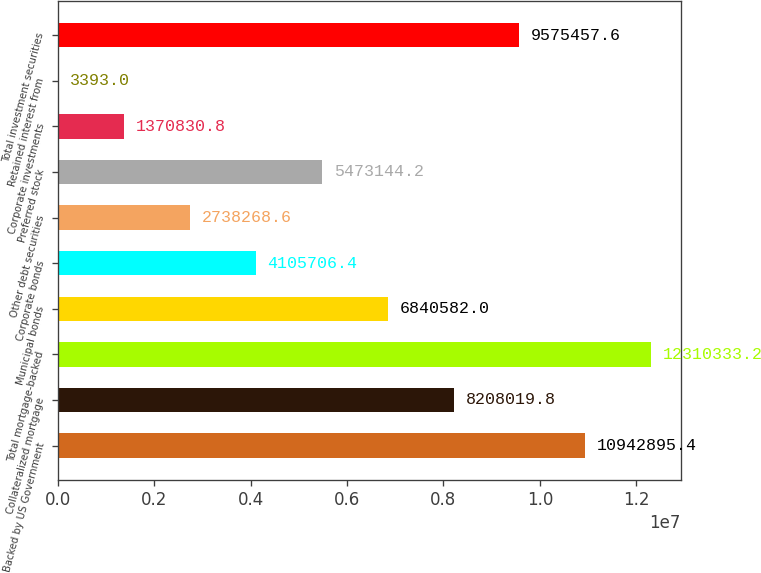<chart> <loc_0><loc_0><loc_500><loc_500><bar_chart><fcel>Backed by US Government<fcel>Collateralized mortgage<fcel>Total mortgage-backed<fcel>Municipal bonds<fcel>Corporate bonds<fcel>Other debt securities<fcel>Preferred stock<fcel>Corporate investments<fcel>Retained interest from<fcel>Total investment securities<nl><fcel>1.09429e+07<fcel>8.20802e+06<fcel>1.23103e+07<fcel>6.84058e+06<fcel>4.10571e+06<fcel>2.73827e+06<fcel>5.47314e+06<fcel>1.37083e+06<fcel>3393<fcel>9.57546e+06<nl></chart> 